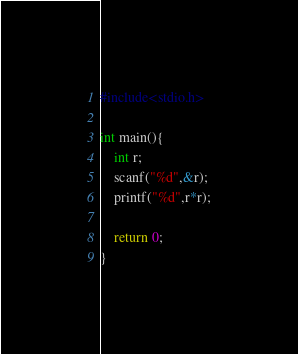Convert code to text. <code><loc_0><loc_0><loc_500><loc_500><_C_>#include<stdio.h>

int main(){
    int r;
    scanf("%d",&r);
    printf("%d",r*r);

    return 0;
}</code> 